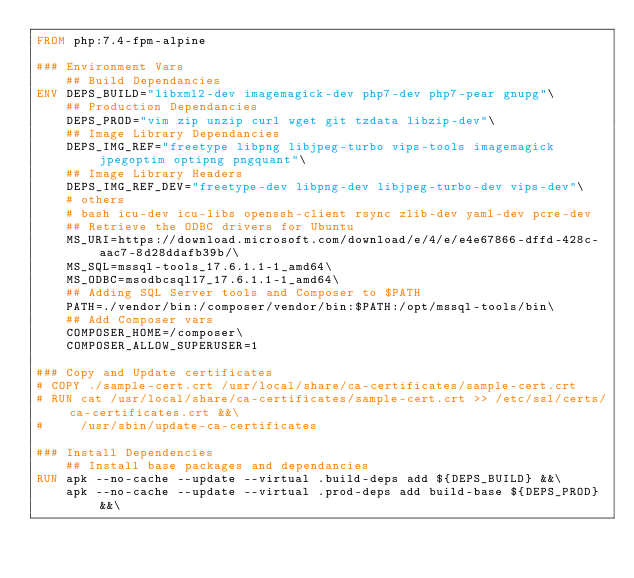<code> <loc_0><loc_0><loc_500><loc_500><_Dockerfile_>FROM php:7.4-fpm-alpine

### Environment Vars
    ## Build Dependancies 
ENV DEPS_BUILD="libxml2-dev imagemagick-dev php7-dev php7-pear gnupg"\
    ## Production Dependancies
    DEPS_PROD="vim zip unzip curl wget git tzdata libzip-dev"\
    ## Image Library Dependancies
    DEPS_IMG_REF="freetype libpng libjpeg-turbo vips-tools imagemagick jpegoptim optipng pngquant"\
    ## Image Library Headers
    DEPS_IMG_REF_DEV="freetype-dev libpng-dev libjpeg-turbo-dev vips-dev"\
    # others
    # bash icu-dev icu-libs openssh-client rsync zlib-dev yaml-dev pcre-dev 
    ## Retrieve the ODBC drivers for Ubuntu
    MS_URI=https://download.microsoft.com/download/e/4/e/e4e67866-dffd-428c-aac7-8d28ddafb39b/\
    MS_SQL=mssql-tools_17.6.1.1-1_amd64\
    MS_ODBC=msodbcsql17_17.6.1.1-1_amd64\
    ## Adding SQL Server tools and Composer to $PATH
    PATH=./vendor/bin:/composer/vendor/bin:$PATH:/opt/mssql-tools/bin\
    ## Add Composer vars
    COMPOSER_HOME=/composer\
    COMPOSER_ALLOW_SUPERUSER=1

### Copy and Update certificates
# COPY ./sample-cert.crt /usr/local/share/ca-certificates/sample-cert.crt
# RUN cat /usr/local/share/ca-certificates/sample-cert.crt >> /etc/ssl/certs/ca-certificates.crt &&\
#     /usr/sbin/update-ca-certificates 

### Install Dependencies
    ## Install base packages and dependancies
RUN apk --no-cache --update --virtual .build-deps add ${DEPS_BUILD} &&\
    apk --no-cache --update --virtual .prod-deps add build-base ${DEPS_PROD} &&\</code> 